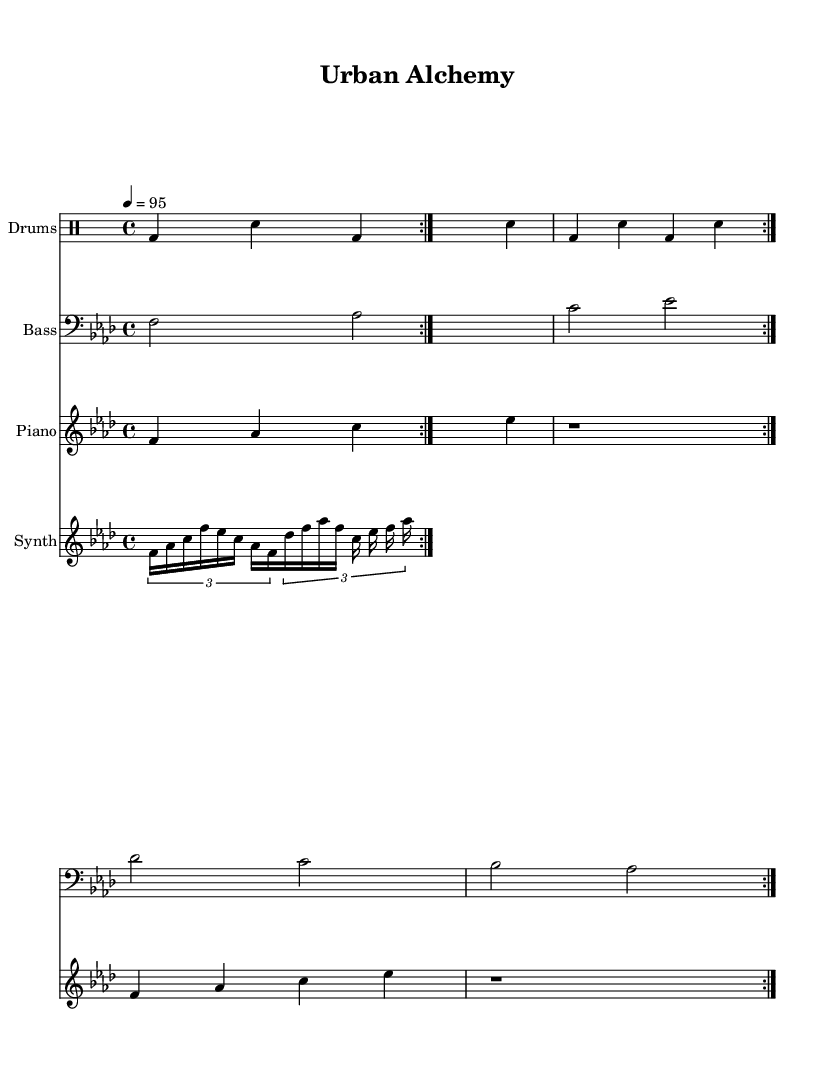What is the key signature of this music? The key signature is F minor, which is indicated by four flats (B flat, E flat, A flat, and D flat) shown at the beginning of the staff.
Answer: F minor What is the time signature of this music? The time signature displayed at the beginning of the sheet music is 4/4, which indicates that there are four beats in each measure and the quarter note receives one beat.
Answer: 4/4 What is the tempo marking of this piece? The tempo marking indicates that the piece should be played at a speed of 95 beats per minute, which is specified at the beginning of the score.
Answer: 95 How many measures are repeated in the drum pattern? The drum pattern is repeated for a total of two measures, as indicated by the "repeat volta 2" instruction.
Answer: 2 What is the rhythmic value of the first note in the piano melody? The first note in the piano melody is a quarter note (F), as it is depicted as having one beat in the scoring.
Answer: Quarter note What type of articulation is used in the synth melody? The synth melody employs tuplets, specifically 3/2, which indicates that three notes are played in the time of two in terms of rhythmic value.
Answer: Tuplets Which instruments play the main melodic lines in this arrangement? The primary melodic lines are performed by the piano and the synth, as indicated by their respective staves in the score.
Answer: Piano and Synth 